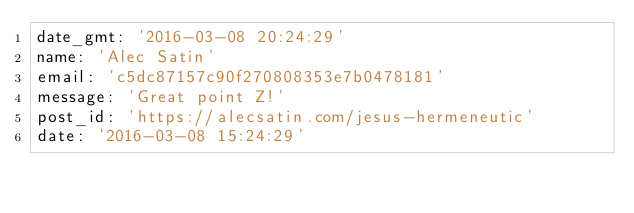<code> <loc_0><loc_0><loc_500><loc_500><_YAML_>date_gmt: '2016-03-08 20:24:29'
name: 'Alec Satin'
email: 'c5dc87157c90f270808353e7b0478181'
message: 'Great point Z!'
post_id: 'https://alecsatin.com/jesus-hermeneutic'
date: '2016-03-08 15:24:29'
</code> 